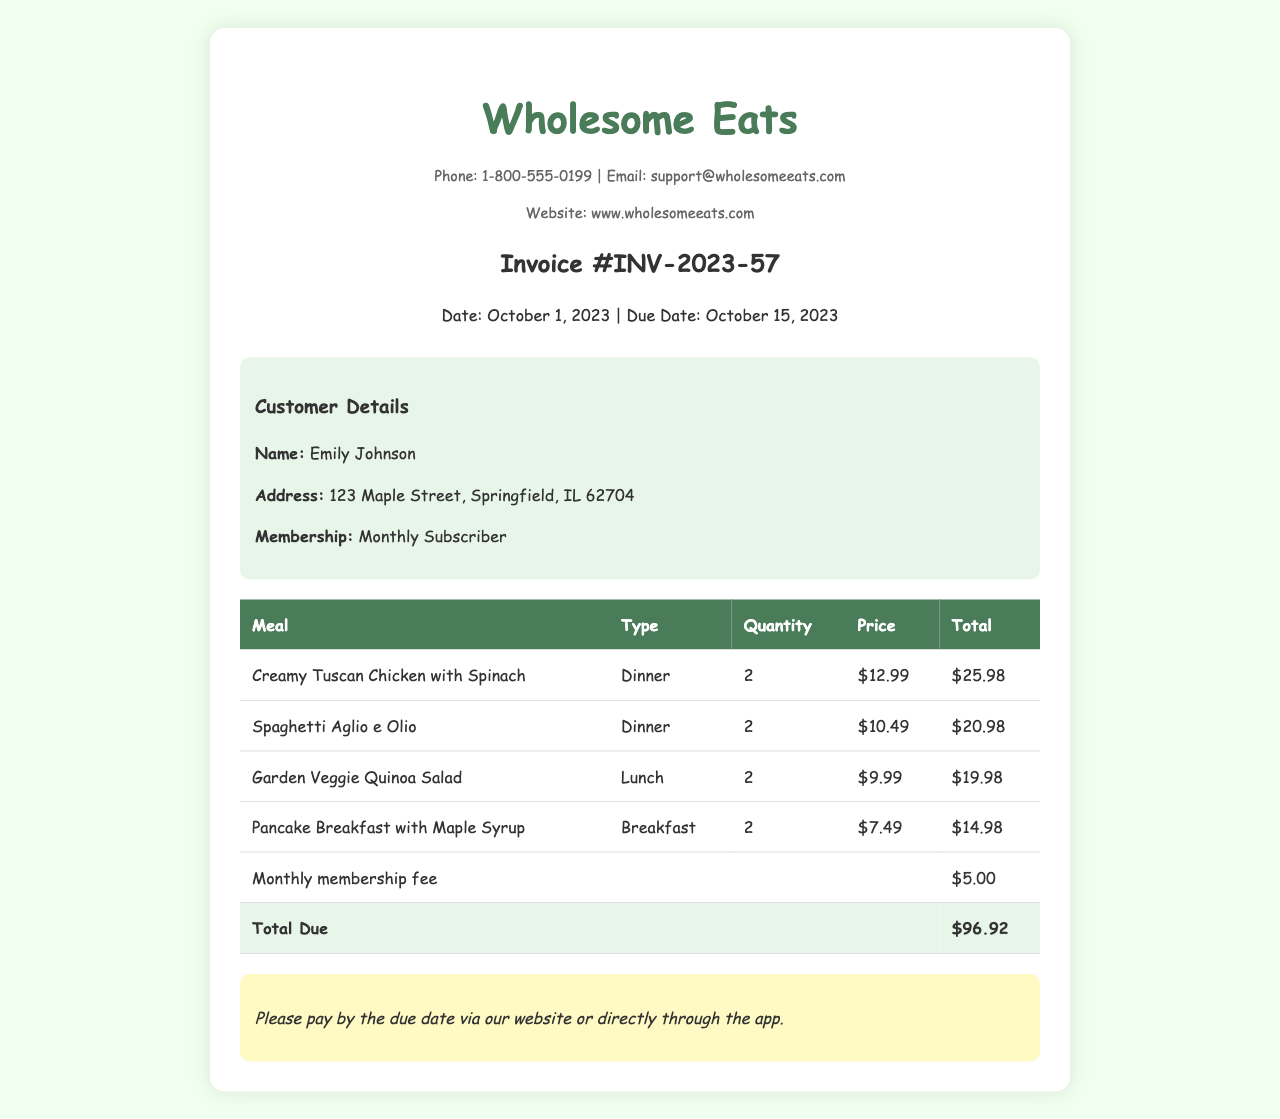what is the invoice number? The invoice number is stated as "Invoice #INV-2023-57."
Answer: INV-2023-57 who is the customer? The name of the customer is mentioned in the document.
Answer: Emily Johnson what is the total due amount? The total due amount is calculated as the sum of all meal totals plus the membership fee.
Answer: $96.92 how many meals are included in the invoice? The invoice lists four unique meals being purchased.
Answer: 4 what is the membership type? The membership type is indicated in the customer details section.
Answer: Monthly Subscriber what meal type has the highest price? The meal type with the highest individual price is found in the meal list.
Answer: Dinner when is the due date for this invoice? The due date is provided prominently in the invoice.
Answer: October 15, 2023 what is the monthly membership fee? The fee is specified in the table as a separate line item.
Answer: $5.00 how many Pancake Breakfasts are ordered? The quantity of Pancake Breakfasts ordered is listed in the meal selection.
Answer: 2 what payment methods are mentioned? The document specifies where payment can be made, which implies the method.
Answer: Via website or app 